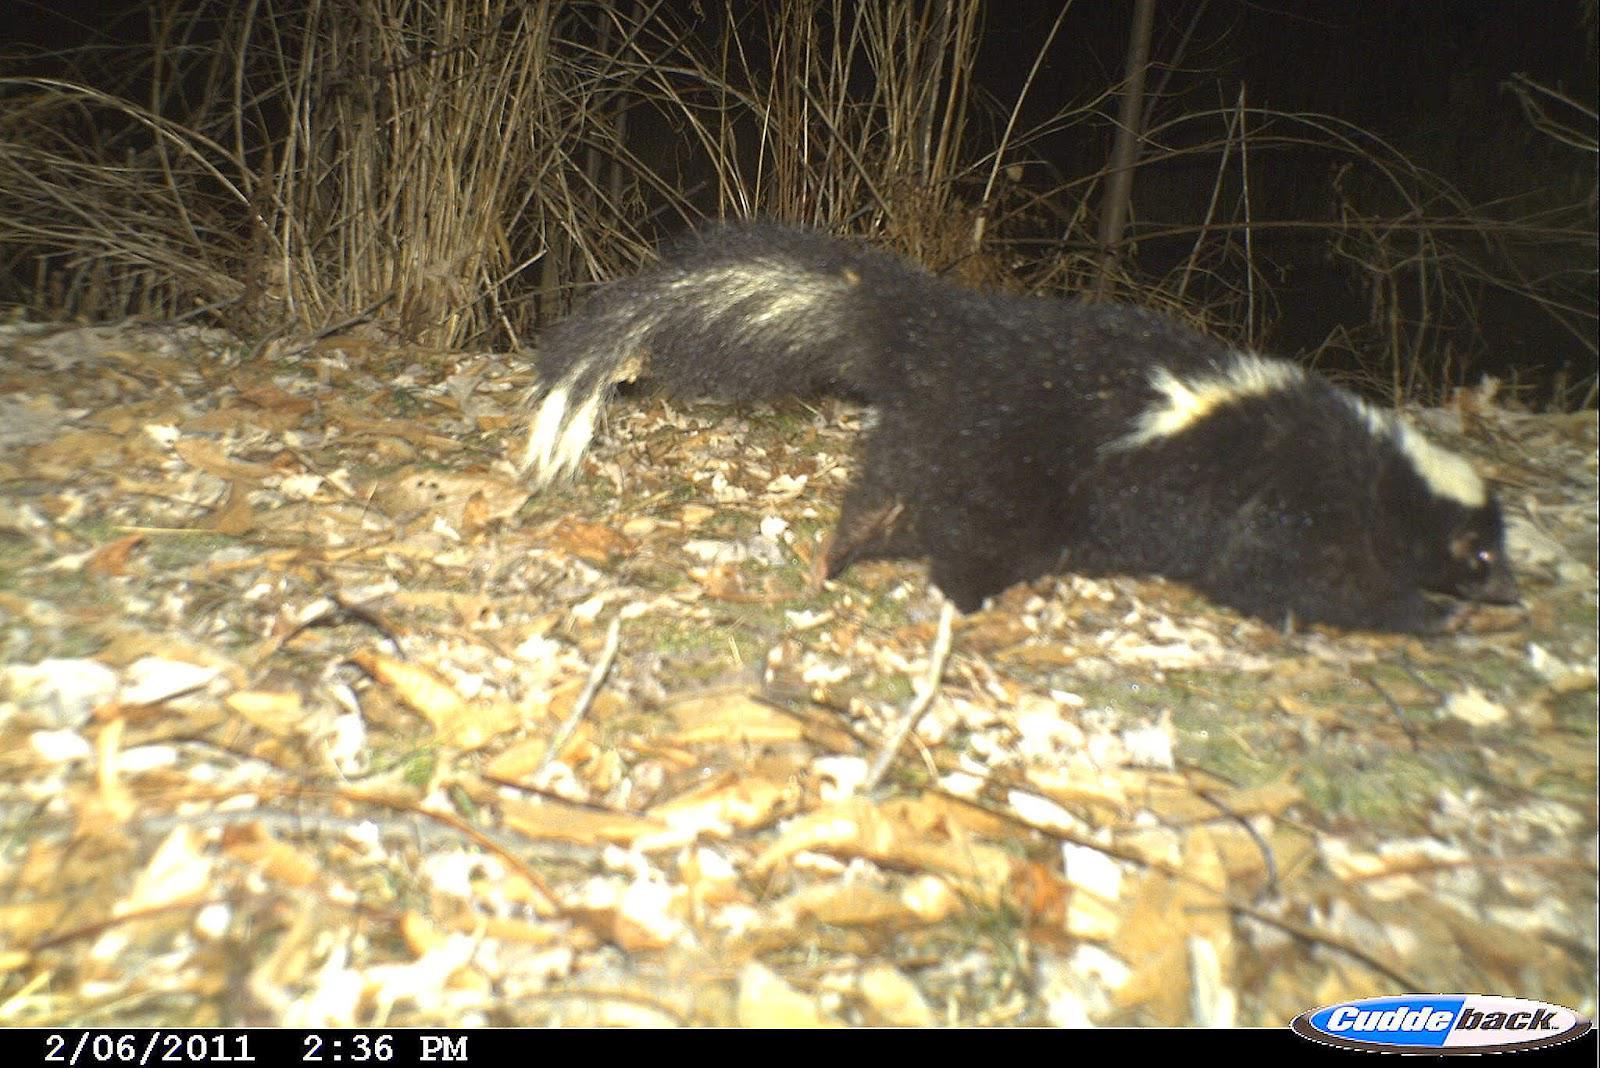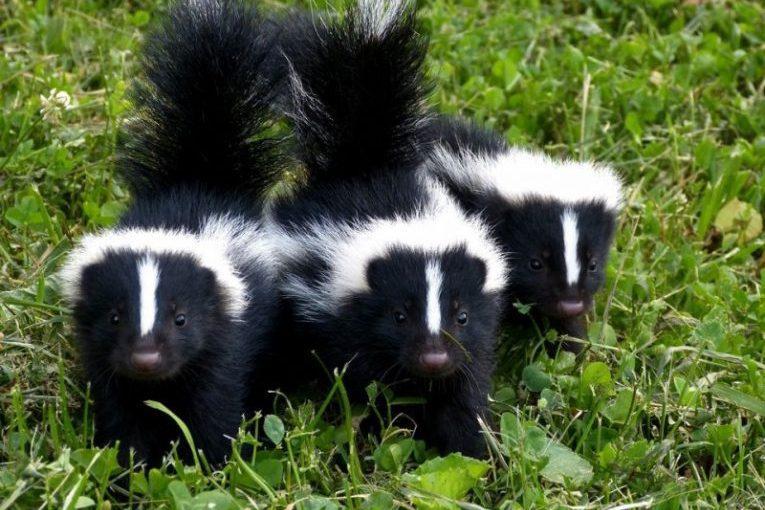The first image is the image on the left, the second image is the image on the right. Assess this claim about the two images: "The skunks in the right image have their tails up.". Correct or not? Answer yes or no. Yes. The first image is the image on the left, the second image is the image on the right. Considering the images on both sides, is "The three skunks on the right are sitting side-by-side in the grass." valid? Answer yes or no. Yes. 